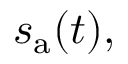Convert formula to latex. <formula><loc_0><loc_0><loc_500><loc_500>s _ { a } ( t ) ,</formula> 